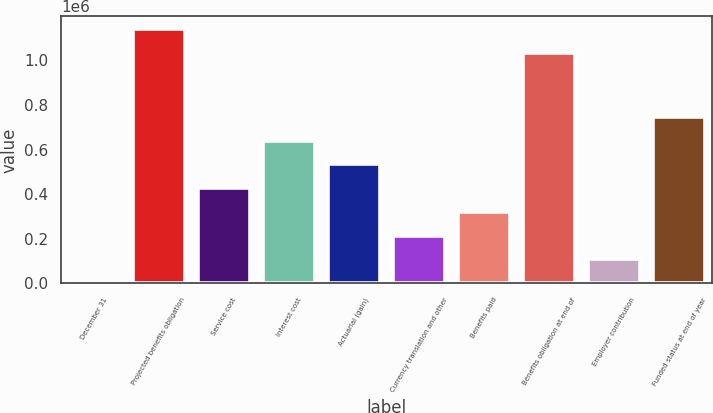Convert chart. <chart><loc_0><loc_0><loc_500><loc_500><bar_chart><fcel>December 31<fcel>Projected benefits obligation<fcel>Service cost<fcel>Interest cost<fcel>Actuarial (gain)<fcel>Currency translation and other<fcel>Benefits paid<fcel>Benefits obligation at end of<fcel>Employer contribution<fcel>Funded status at end of year<nl><fcel>2007<fcel>1.13966e+06<fcel>427341<fcel>640008<fcel>533674<fcel>214674<fcel>321008<fcel>1.03332e+06<fcel>108340<fcel>746342<nl></chart> 